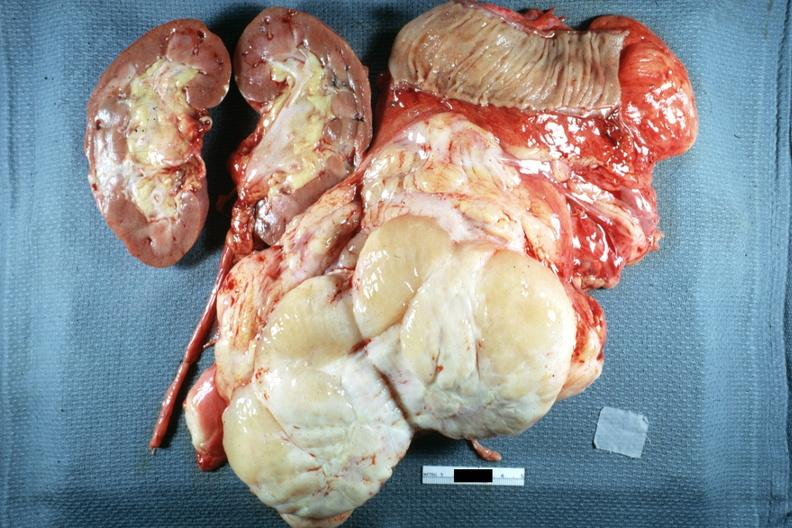what is present?
Answer the question using a single word or phrase. Abdomen 